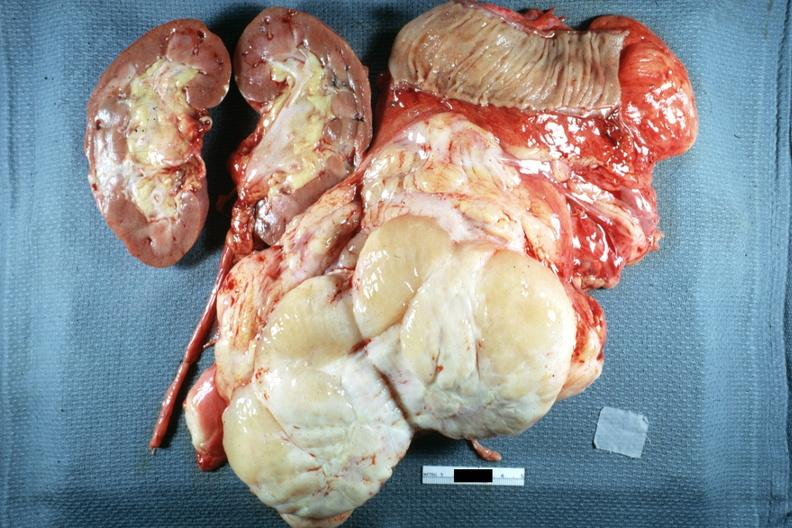what is present?
Answer the question using a single word or phrase. Abdomen 